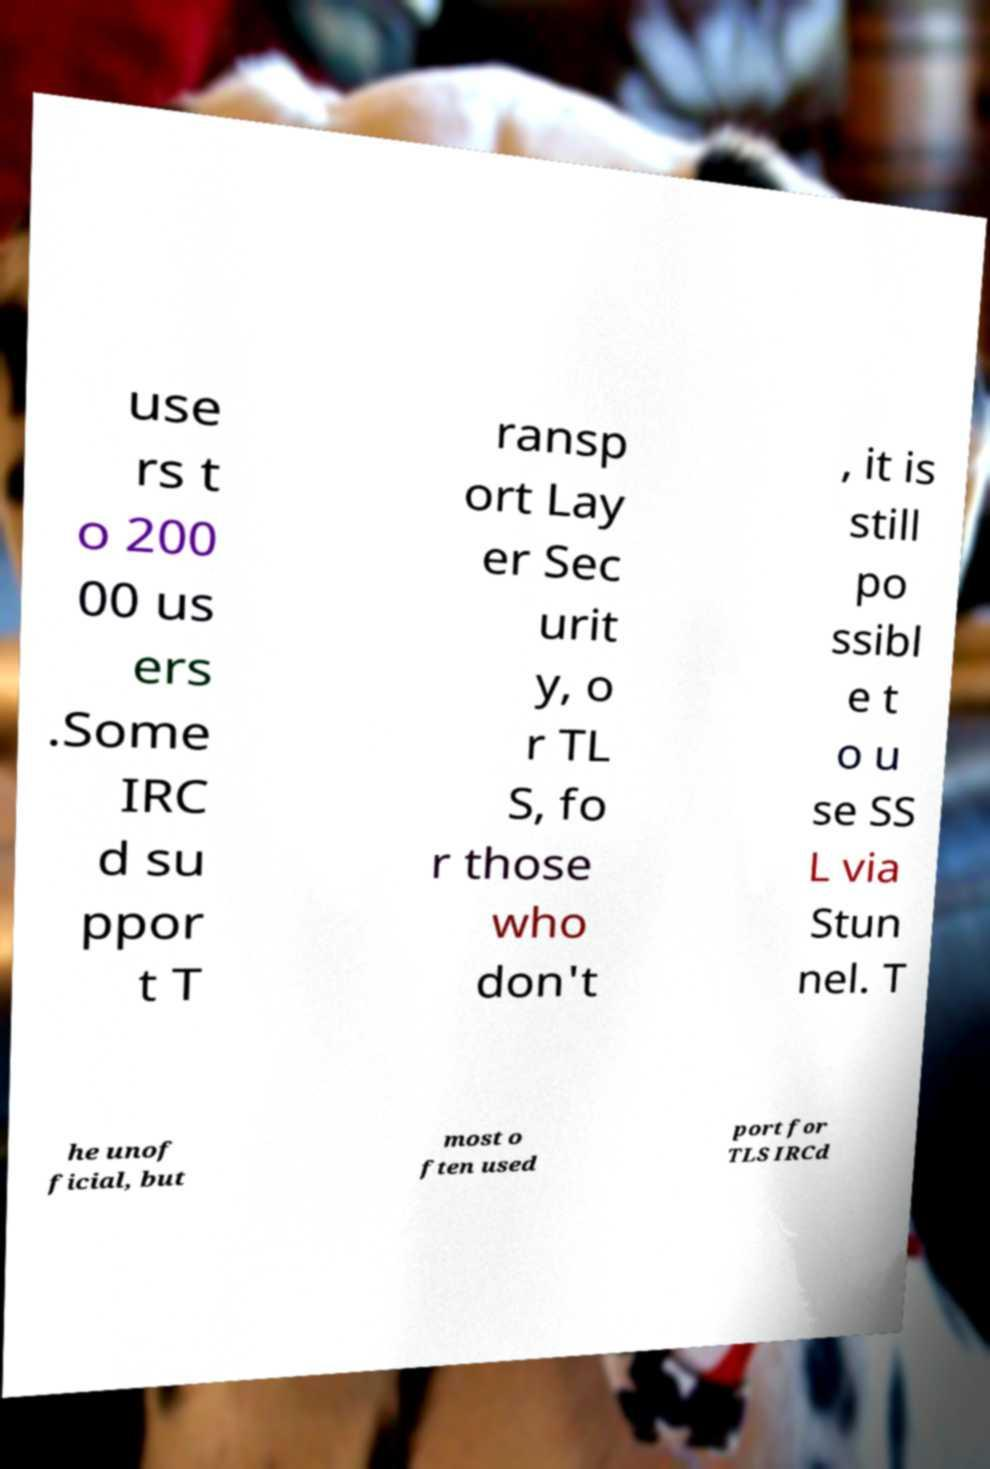Please identify and transcribe the text found in this image. use rs t o 200 00 us ers .Some IRC d su ppor t T ransp ort Lay er Sec urit y, o r TL S, fo r those who don't , it is still po ssibl e t o u se SS L via Stun nel. T he unof ficial, but most o ften used port for TLS IRCd 